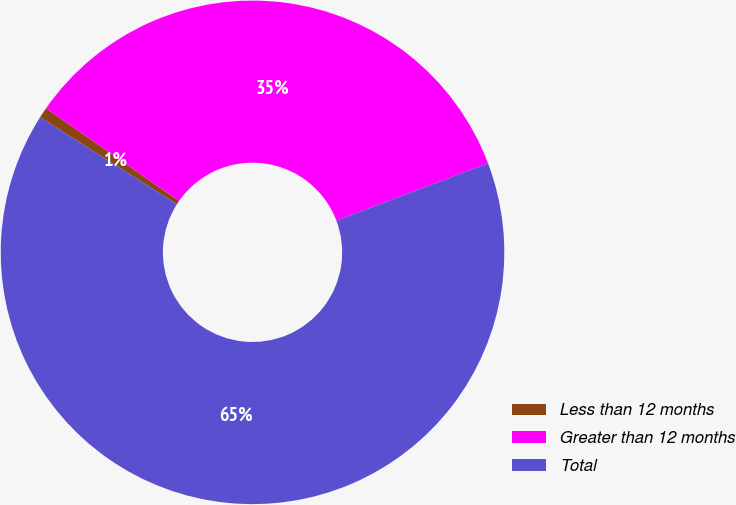<chart> <loc_0><loc_0><loc_500><loc_500><pie_chart><fcel>Less than 12 months<fcel>Greater than 12 months<fcel>Total<nl><fcel>0.68%<fcel>34.55%<fcel>64.77%<nl></chart> 